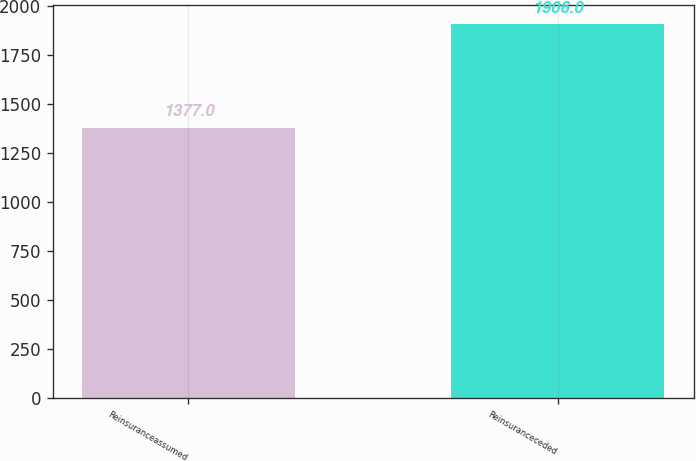<chart> <loc_0><loc_0><loc_500><loc_500><bar_chart><fcel>Reinsuranceassumed<fcel>Reinsuranceceded<nl><fcel>1377<fcel>1906<nl></chart> 